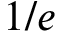<formula> <loc_0><loc_0><loc_500><loc_500>1 / e</formula> 